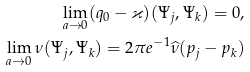Convert formula to latex. <formula><loc_0><loc_0><loc_500><loc_500>\lim _ { a \to 0 } ( q _ { 0 } - \varkappa ) ( \Psi _ { j } , \Psi _ { k } ) = 0 , \\ \lim _ { a \to 0 } \nu ( \Psi _ { j } , \Psi _ { k } ) = 2 \pi e ^ { - 1 } \widehat { \nu } ( p _ { j } - p _ { k } )</formula> 